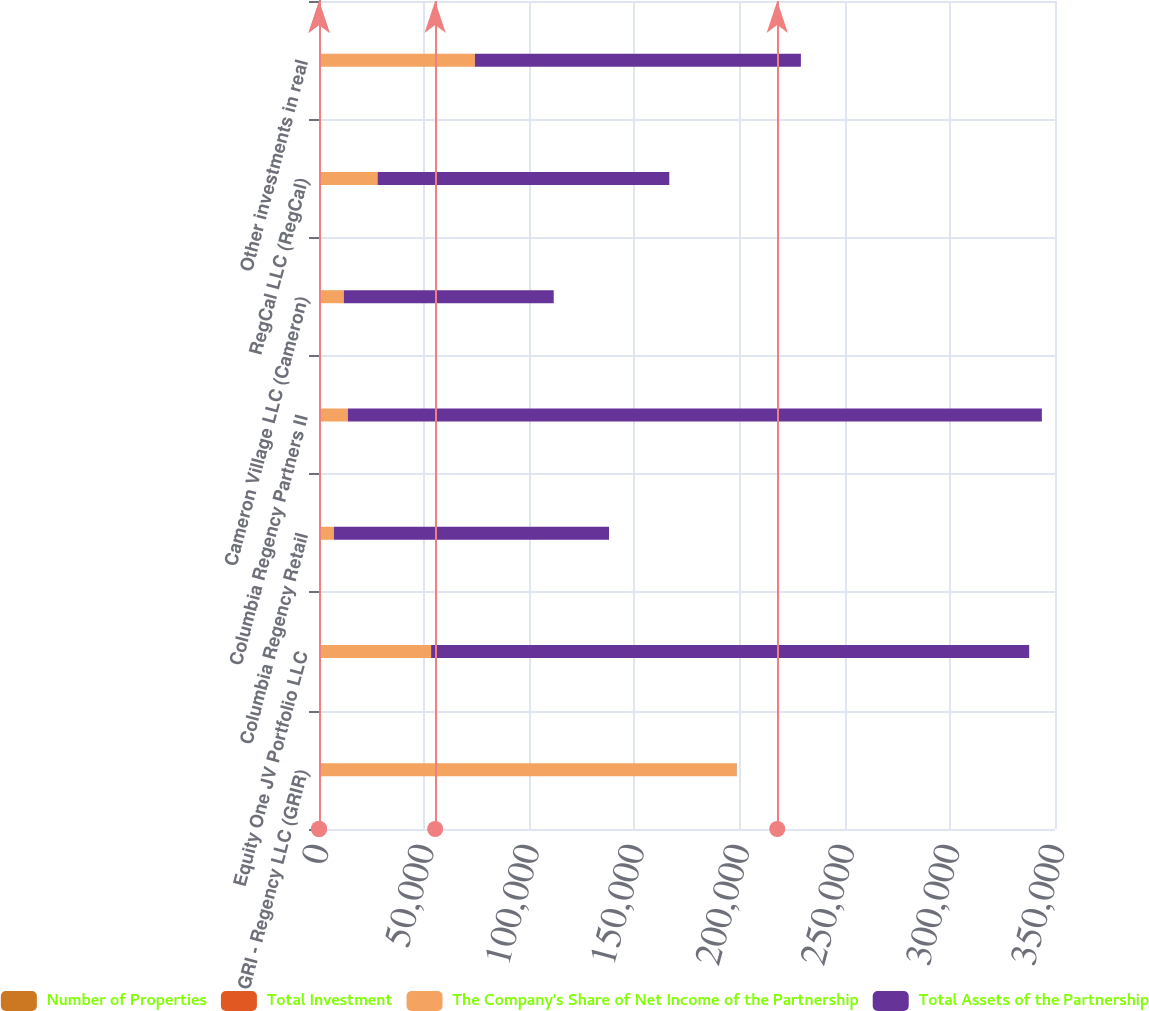Convert chart. <chart><loc_0><loc_0><loc_500><loc_500><stacked_bar_chart><ecel><fcel>GRI - Regency LLC (GRIR)<fcel>Equity One JV Portfolio LLC<fcel>Columbia Regency Retail<fcel>Columbia Regency Partners II<fcel>Cameron Village LLC (Cameron)<fcel>RegCal LLC (RegCal)<fcel>Other investments in real<nl><fcel>Number of Properties<fcel>40<fcel>30<fcel>20<fcel>20<fcel>30<fcel>25<fcel>50<nl><fcel>Total Investment<fcel>70<fcel>6<fcel>6<fcel>12<fcel>1<fcel>7<fcel>6<nl><fcel>The Company's Share of Net Income of the Partnership<fcel>198521<fcel>53277<fcel>7057<fcel>13720<fcel>11784<fcel>27829<fcel>74116<nl><fcel>Total Assets of the Partnership<fcel>70<fcel>284412<fcel>130836<fcel>329992<fcel>99808<fcel>138717<fcel>154987<nl></chart> 